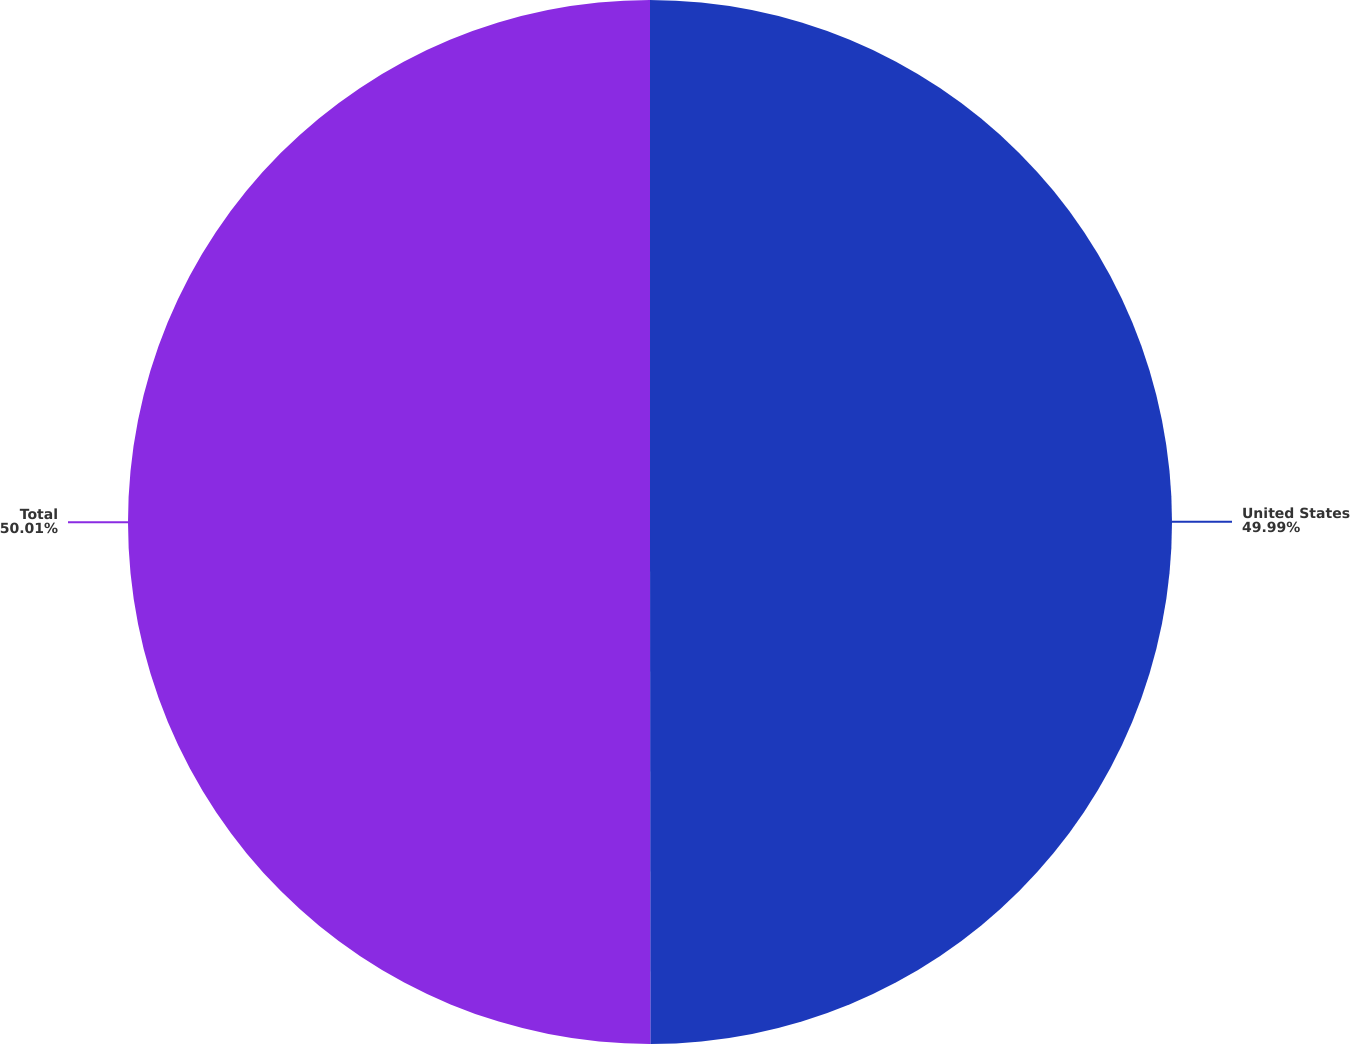Convert chart to OTSL. <chart><loc_0><loc_0><loc_500><loc_500><pie_chart><fcel>United States<fcel>Total<nl><fcel>49.99%<fcel>50.01%<nl></chart> 